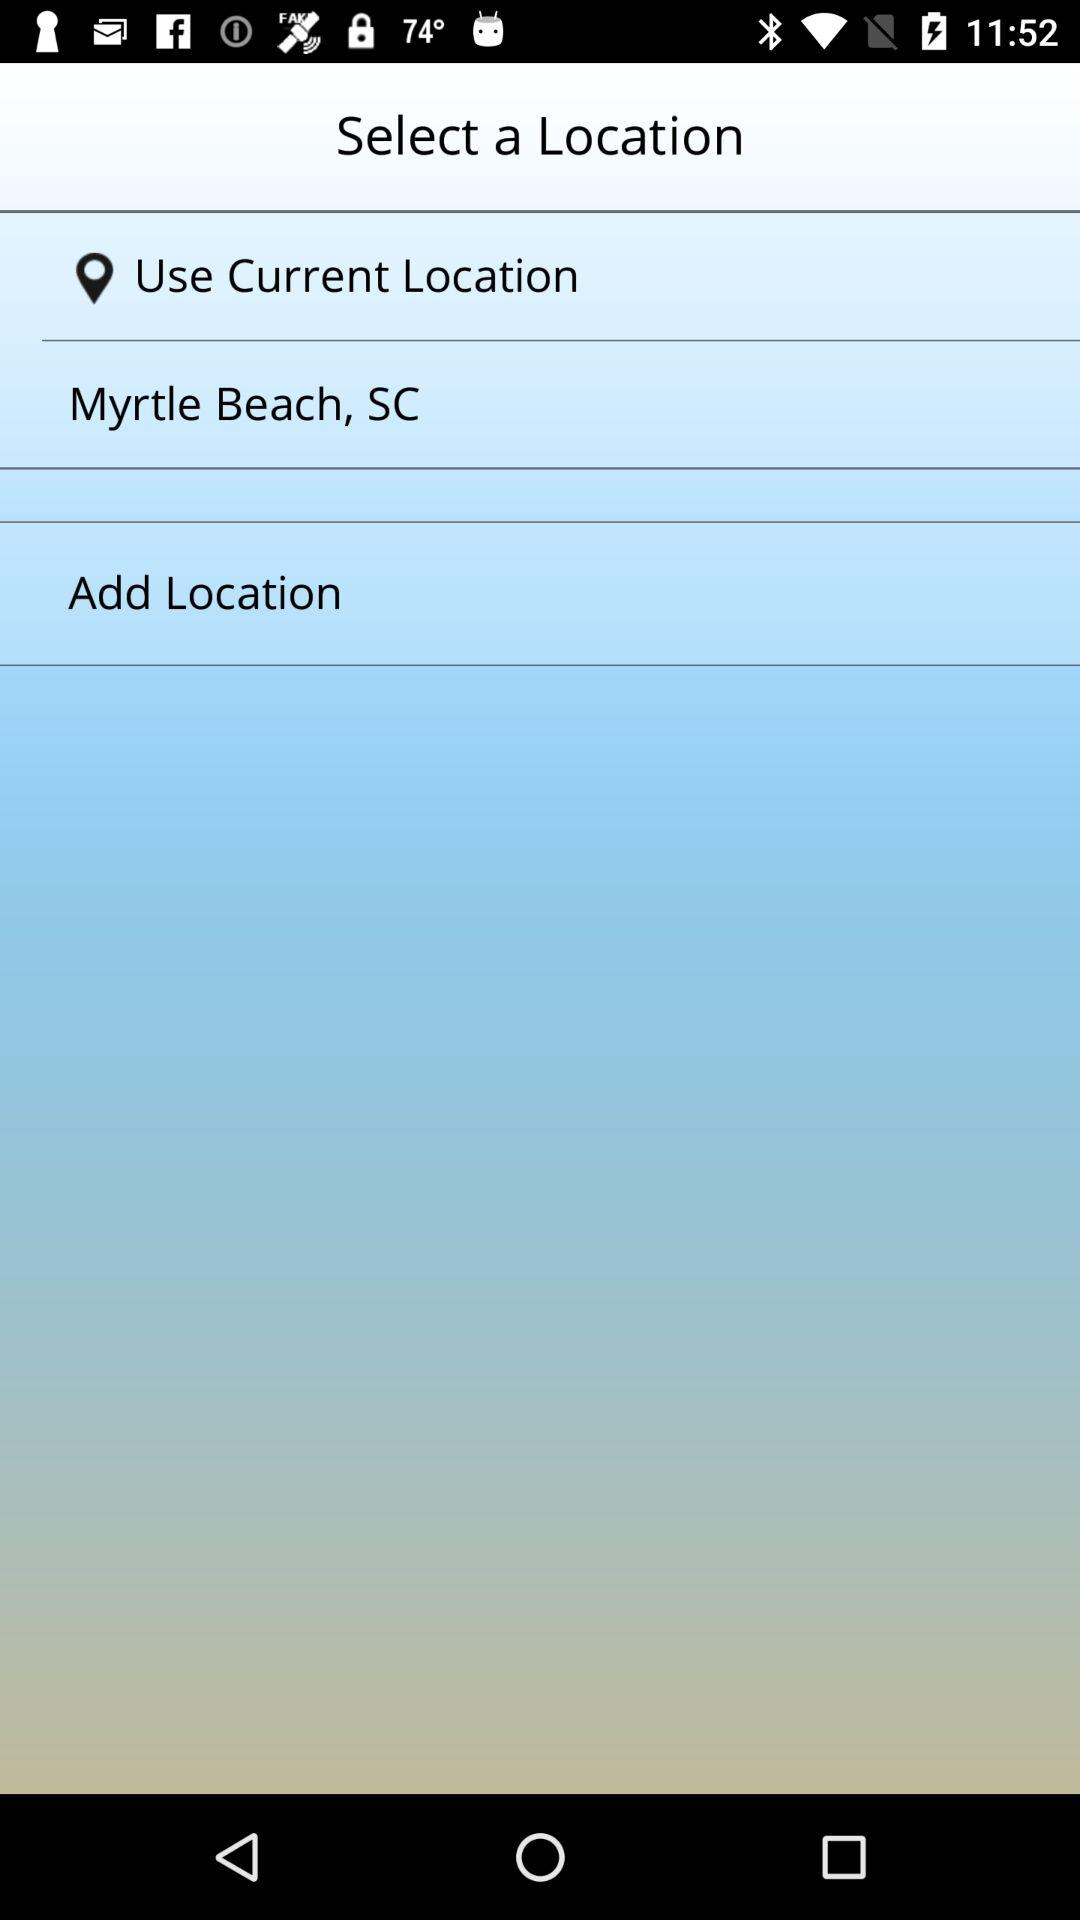How many locations can be added?
When the provided information is insufficient, respond with <no answer>. <no answer> 